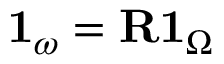<formula> <loc_0><loc_0><loc_500><loc_500>1 _ { \omega } = R 1 _ { \Omega }</formula> 